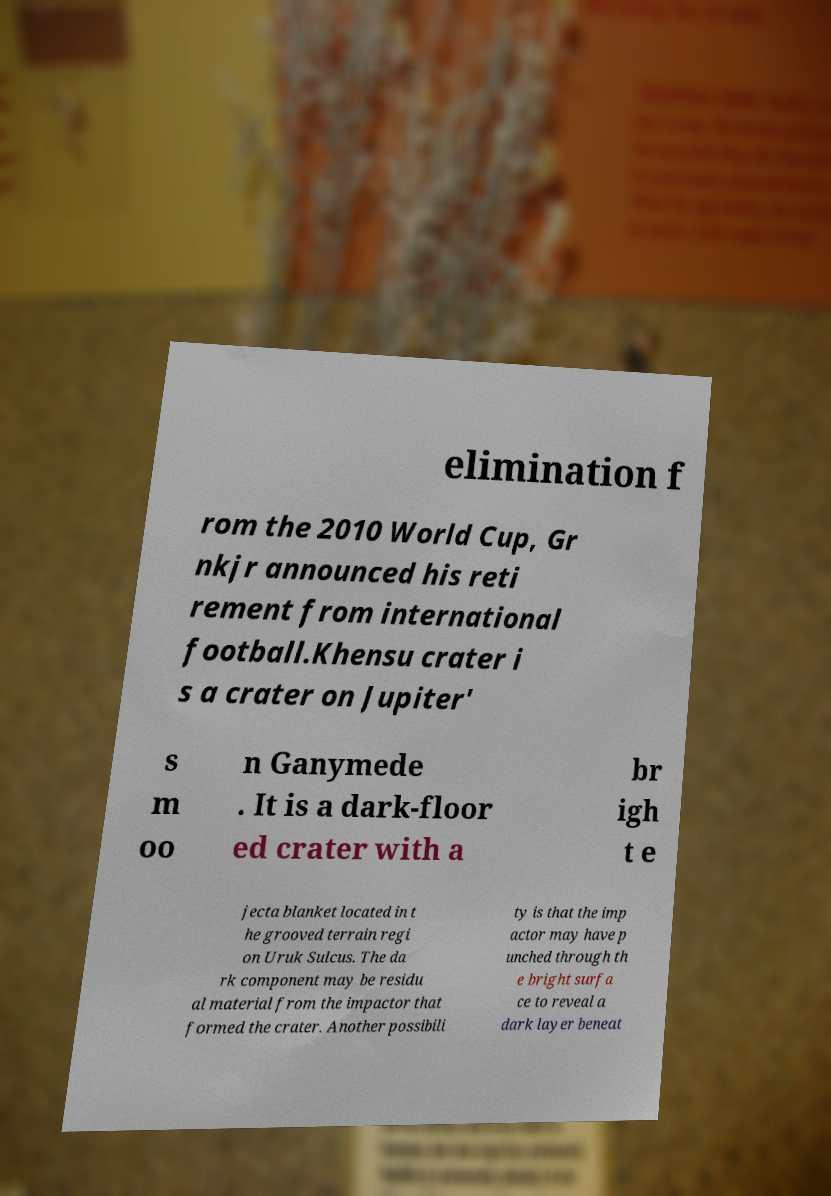Please identify and transcribe the text found in this image. elimination f rom the 2010 World Cup, Gr nkjr announced his reti rement from international football.Khensu crater i s a crater on Jupiter' s m oo n Ganymede . It is a dark-floor ed crater with a br igh t e jecta blanket located in t he grooved terrain regi on Uruk Sulcus. The da rk component may be residu al material from the impactor that formed the crater. Another possibili ty is that the imp actor may have p unched through th e bright surfa ce to reveal a dark layer beneat 